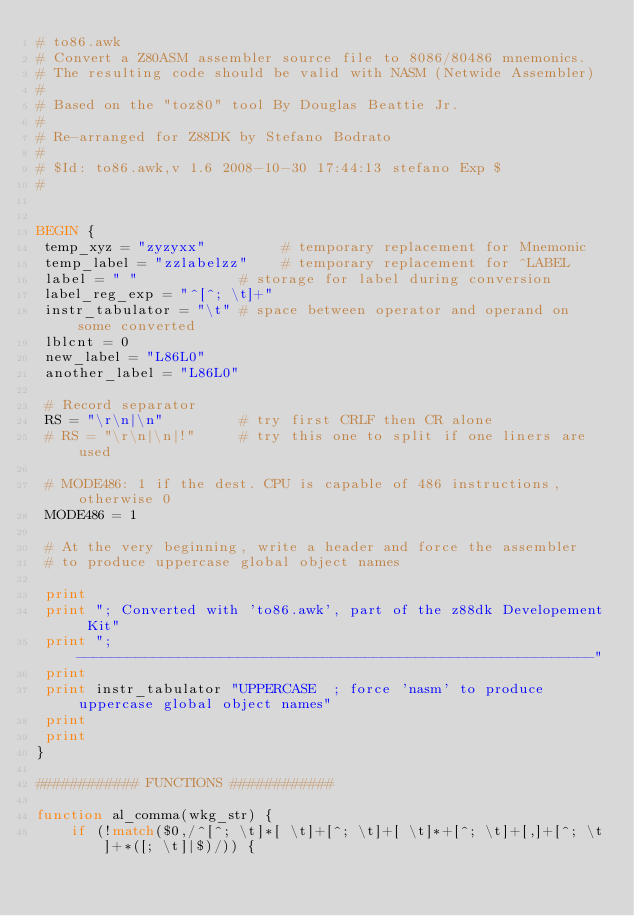Convert code to text. <code><loc_0><loc_0><loc_500><loc_500><_Awk_># to86.awk
# Convert a Z80ASM assembler source file to 8086/80486 mnemonics.
# The resulting code should be valid with NASM (Netwide Assembler)
#
# Based on the "toz80" tool By Douglas Beattie Jr.
#
# Re-arranged for Z88DK by Stefano Bodrato
#
# $Id: to86.awk,v 1.6 2008-10-30 17:44:13 stefano Exp $
#


BEGIN {
 temp_xyz = "zyzyxx"         # temporary replacement for Mnemonic
 temp_label = "zzlabelzz"    # temporary replacement for ^LABEL
 label = " "            # storage for label during conversion
 label_reg_exp = "^[^; \t]+"
 instr_tabulator = "\t" # space between operator and operand on some converted
 lblcnt = 0
 new_label = "L86L0"
 another_label = "L86L0"

 # Record separator
 RS = "\r\n|\n"         # try first CRLF then CR alone
 # RS = "\r\n|\n|!"     # try this one to split if one liners are used

 # MODE486: 1 if the dest. CPU is capable of 486 instructions, otherwise 0
 MODE486 = 1

 # At the very beginning, write a header and force the assembler 
 # to produce uppercase global object names

 print
 print "; Converted with 'to86.awk', part of the z88dk Developement Kit"
 print "; -------------------------------------------------------------"
 print
 print instr_tabulator "UPPERCASE  ; force 'nasm' to produce uppercase global object names"
 print
 print
}

############ FUNCTIONS ############

function al_comma(wkg_str) {
    if (!match($0,/^[^; \t]*[ \t]+[^; \t]+[ \t]*+[^; \t]+[,]+[^; \t]+*([; \t]|$)/)) {</code> 